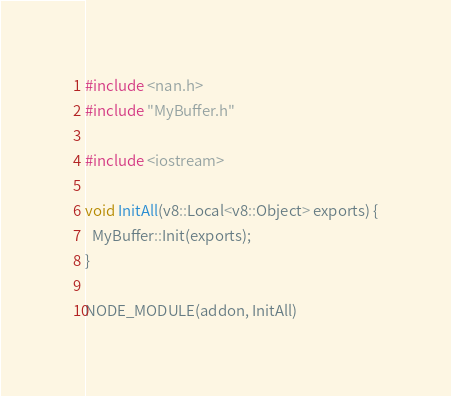<code> <loc_0><loc_0><loc_500><loc_500><_C++_>
#include <nan.h>
#include "MyBuffer.h"

#include <iostream>

void InitAll(v8::Local<v8::Object> exports) {
  MyBuffer::Init(exports);
}

NODE_MODULE(addon, InitAll)</code> 